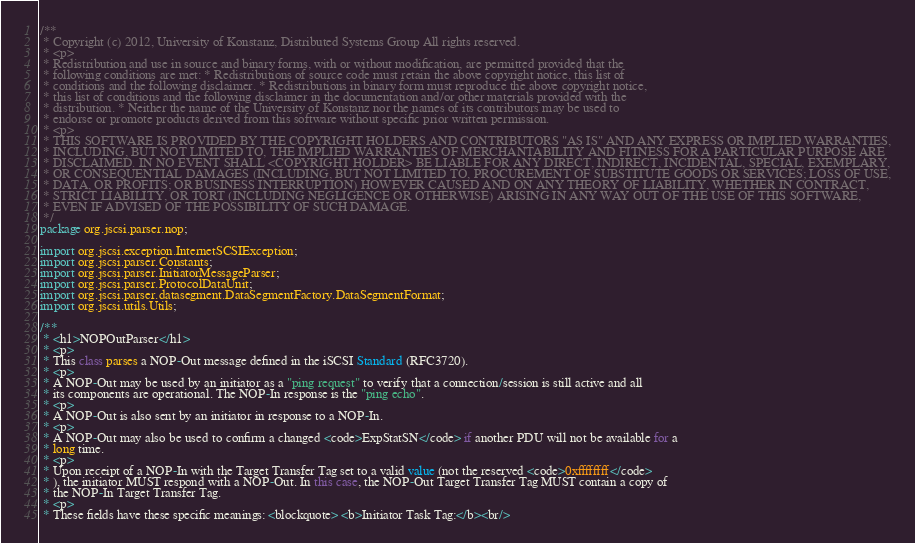<code> <loc_0><loc_0><loc_500><loc_500><_Java_>/**
 * Copyright (c) 2012, University of Konstanz, Distributed Systems Group All rights reserved.
 * <p>
 * Redistribution and use in source and binary forms, with or without modification, are permitted provided that the
 * following conditions are met: * Redistributions of source code must retain the above copyright notice, this list of
 * conditions and the following disclaimer. * Redistributions in binary form must reproduce the above copyright notice,
 * this list of conditions and the following disclaimer in the documentation and/or other materials provided with the
 * distribution. * Neither the name of the University of Konstanz nor the names of its contributors may be used to
 * endorse or promote products derived from this software without specific prior written permission.
 * <p>
 * THIS SOFTWARE IS PROVIDED BY THE COPYRIGHT HOLDERS AND CONTRIBUTORS "AS IS" AND ANY EXPRESS OR IMPLIED WARRANTIES,
 * INCLUDING, BUT NOT LIMITED TO, THE IMPLIED WARRANTIES OF MERCHANTABILITY AND FITNESS FOR A PARTICULAR PURPOSE ARE
 * DISCLAIMED. IN NO EVENT SHALL <COPYRIGHT HOLDER> BE LIABLE FOR ANY DIRECT, INDIRECT, INCIDENTAL, SPECIAL, EXEMPLARY,
 * OR CONSEQUENTIAL DAMAGES (INCLUDING, BUT NOT LIMITED TO, PROCUREMENT OF SUBSTITUTE GOODS OR SERVICES; LOSS OF USE,
 * DATA, OR PROFITS; OR BUSINESS INTERRUPTION) HOWEVER CAUSED AND ON ANY THEORY OF LIABILITY, WHETHER IN CONTRACT,
 * STRICT LIABILITY, OR TORT (INCLUDING NEGLIGENCE OR OTHERWISE) ARISING IN ANY WAY OUT OF THE USE OF THIS SOFTWARE,
 * EVEN IF ADVISED OF THE POSSIBILITY OF SUCH DAMAGE.
 */
package org.jscsi.parser.nop;

import org.jscsi.exception.InternetSCSIException;
import org.jscsi.parser.Constants;
import org.jscsi.parser.InitiatorMessageParser;
import org.jscsi.parser.ProtocolDataUnit;
import org.jscsi.parser.datasegment.DataSegmentFactory.DataSegmentFormat;
import org.jscsi.utils.Utils;

/**
 * <h1>NOPOutParser</h1>
 * <p>
 * This class parses a NOP-Out message defined in the iSCSI Standard (RFC3720).
 * <p>
 * A NOP-Out may be used by an initiator as a "ping request" to verify that a connection/session is still active and all
 * its components are operational. The NOP-In response is the "ping echo".
 * <p>
 * A NOP-Out is also sent by an initiator in response to a NOP-In.
 * <p>
 * A NOP-Out may also be used to confirm a changed <code>ExpStatSN</code> if another PDU will not be available for a
 * long time.
 * <p>
 * Upon receipt of a NOP-In with the Target Transfer Tag set to a valid value (not the reserved <code>0xffffffff</code>
 * ), the initiator MUST respond with a NOP-Out. In this case, the NOP-Out Target Transfer Tag MUST contain a copy of
 * the NOP-In Target Transfer Tag.
 * <p>
 * These fields have these specific meanings: <blockquote> <b>Initiator Task Tag:</b><br/></code> 